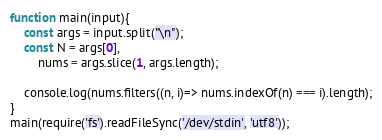<code> <loc_0><loc_0><loc_500><loc_500><_JavaScript_>function main(input){
    const args = input.split("\n");
    const N = args[0],
        nums = args.slice(1, args.length);
    
    console.log(nums.filters((n, i)=> nums.indexOf(n) === i).length);
}
main(require('fs').readFileSync('/dev/stdin', 'utf8'));</code> 